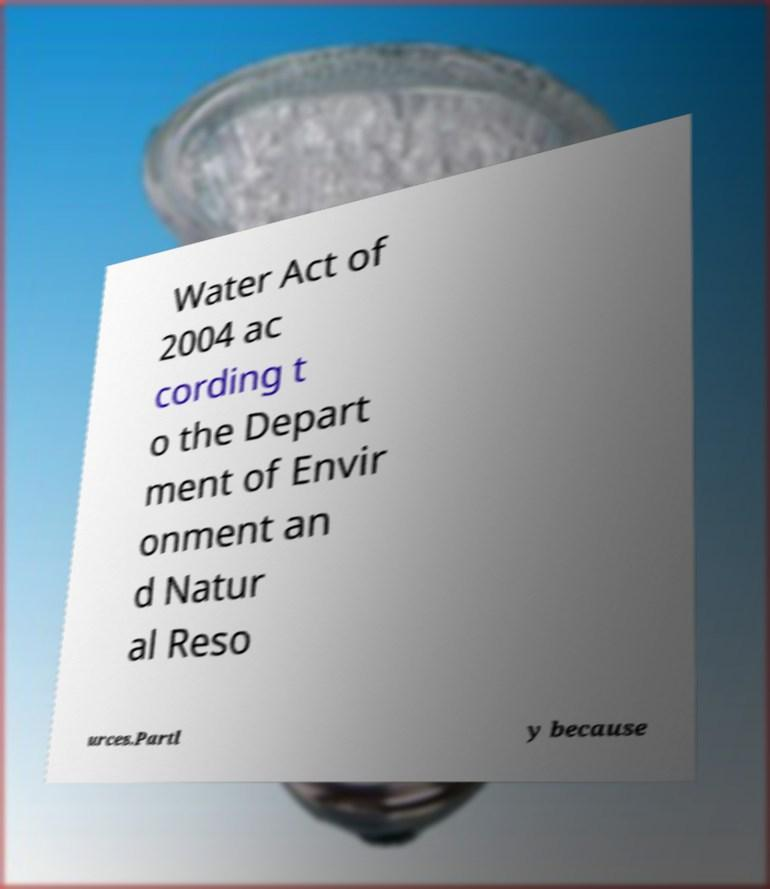Please identify and transcribe the text found in this image. Water Act of 2004 ac cording t o the Depart ment of Envir onment an d Natur al Reso urces.Partl y because 